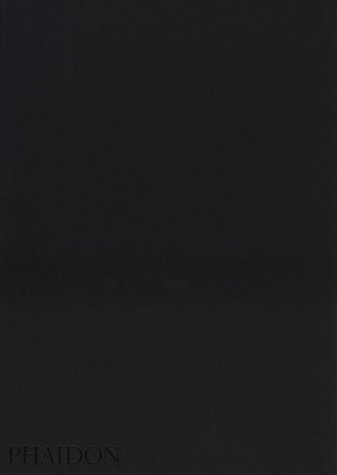Who is the author of this book? The book titled 'The Mennonites' is authored by Larry Towell, a renowned photographer and member of the Magnum Photos agency who is notable for his documentary works. 